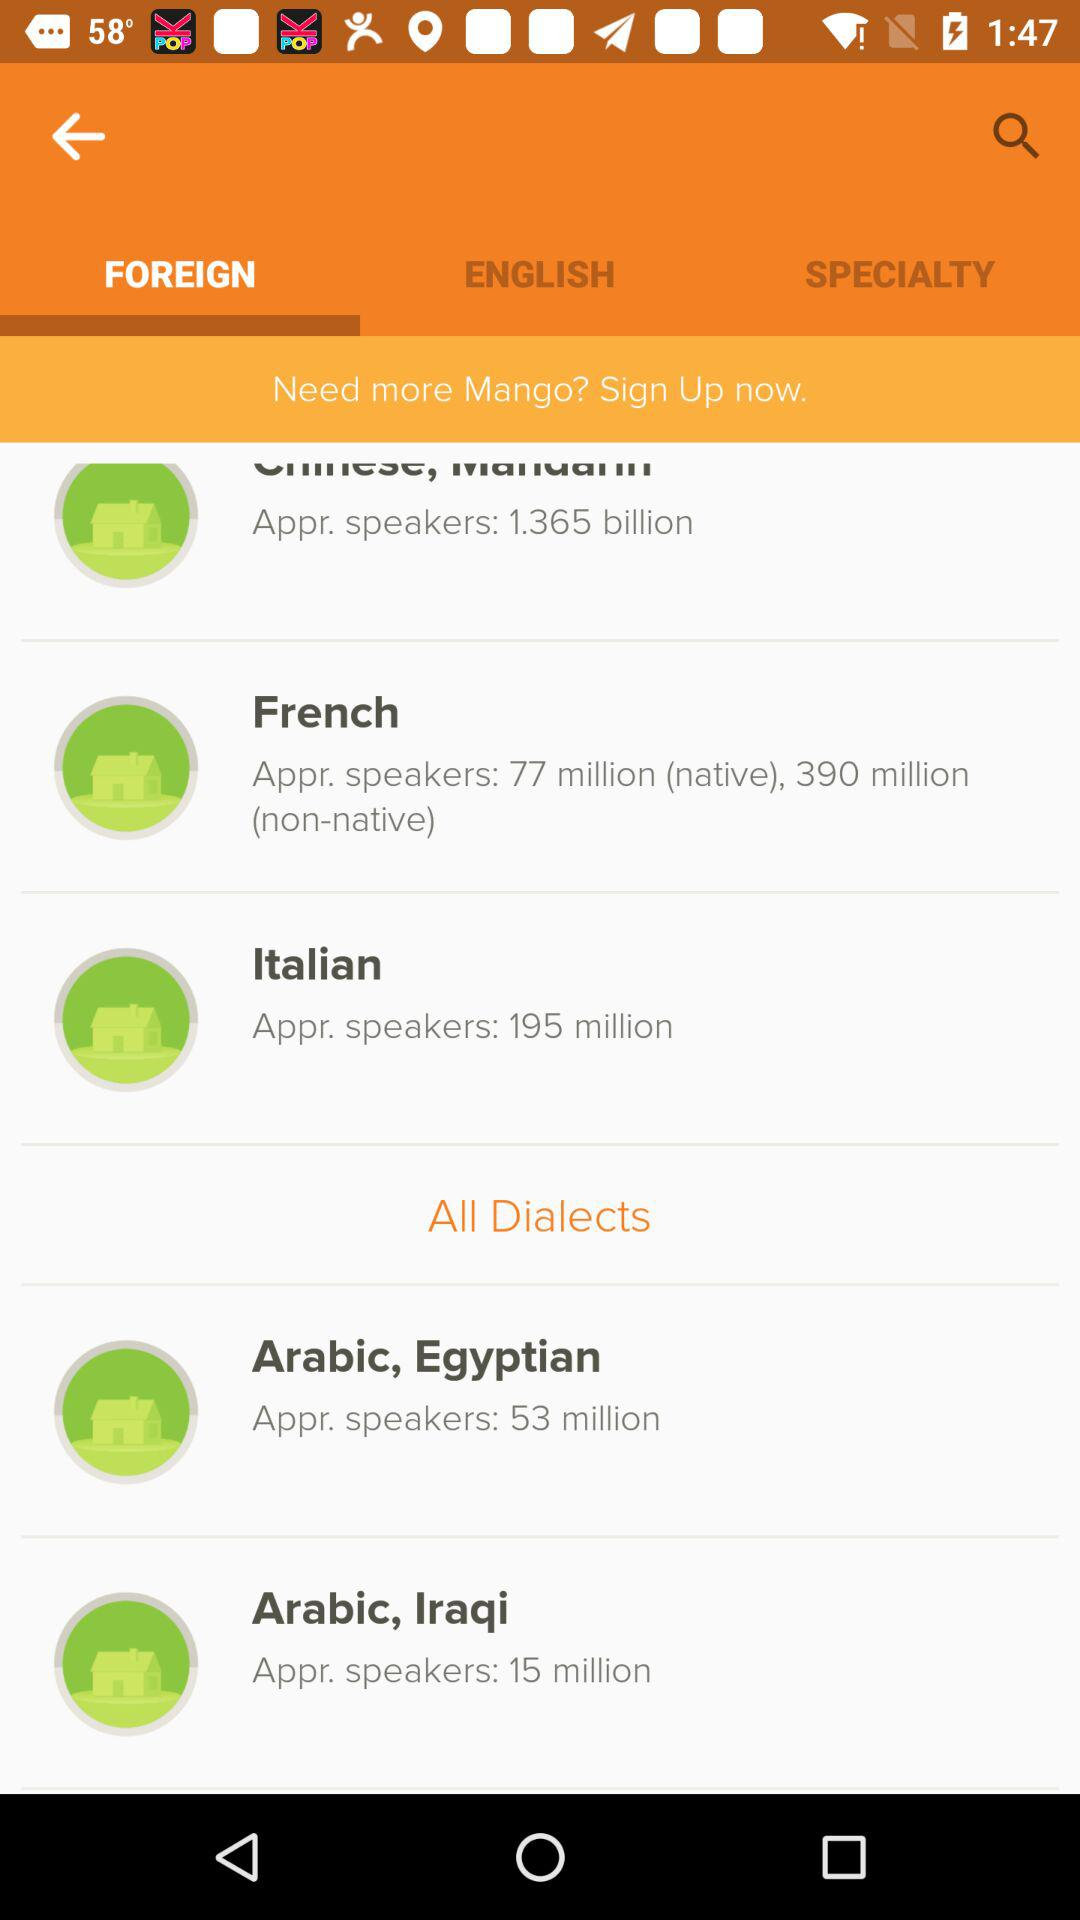What is the name of the dialect that has 53 million approximate speakers? The name of the dialect is Arabic, Egyptian. 